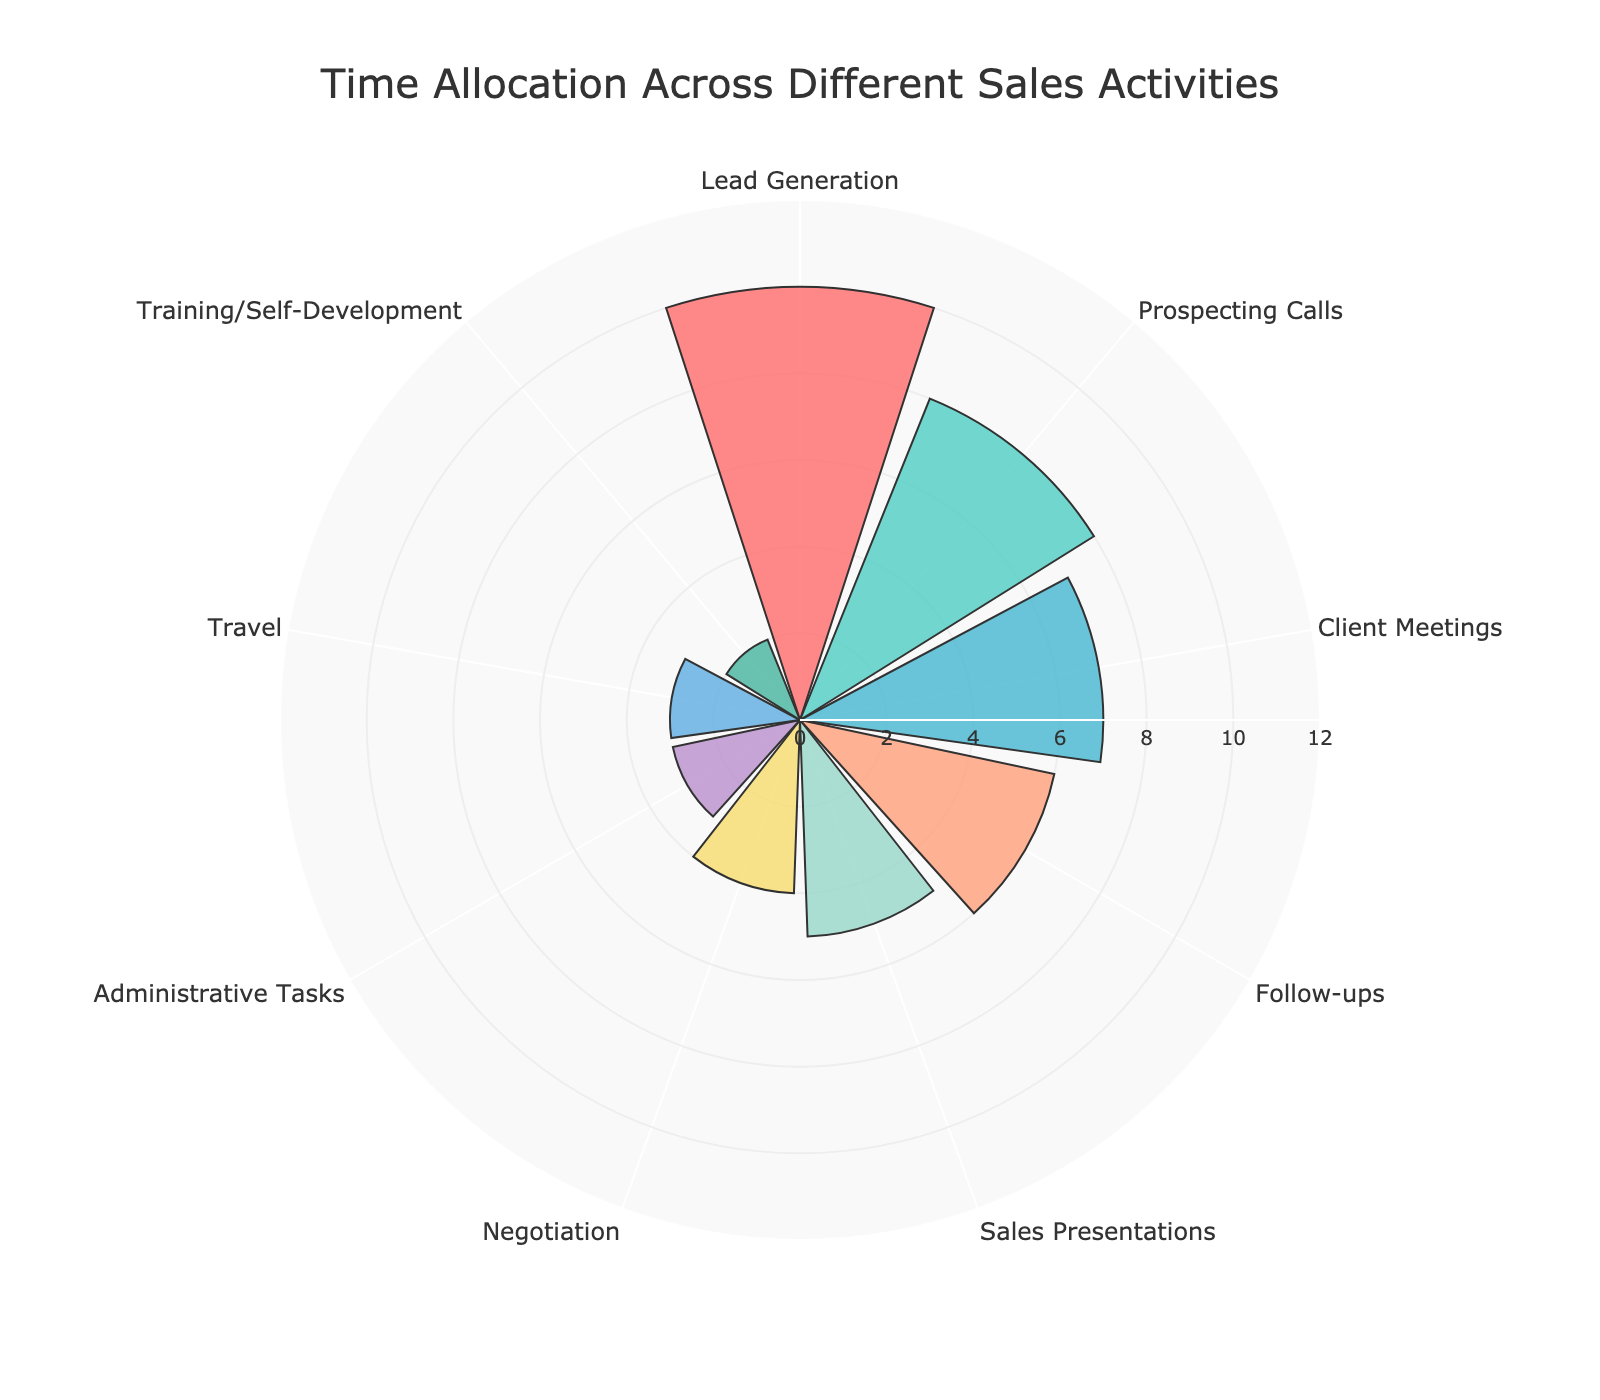what is the title of the figure? The title of the figure is displayed at the top of the chart. It is "Time Allocation Across Different Sales Activities".
Answer: Time Allocation Across Different Sales Activities how many activities are shown in the chart? By counting the segments labeled around the polar area chart, there are 9 different activities displayed.
Answer: 9 which activity takes the most hours per week? The activity with the longest bar (largest radius) represents the most hours. "Lead Generation" takes the most time with 10 hours per week.
Answer: Lead Generation how many more hours are spent on lead generation than on administrative tasks? Lead Generation takes 10 hours and Administrative Tasks take 3 hours. The difference is 10 - 3.
Answer: 7 what activities take 5 or more hours per week? By observing the chart and identifying the bars with radii of 5 or more hours, the activities are: Lead Generation (10), Prospecting Calls (8), Client Meetings (7), Follow-ups (6), and Sales Presentations (5).
Answer: Lead Generation, Prospecting Calls, Client Meetings, Follow-ups, Sales Presentations what is the combined amount of time spent on negotiation and sales presentations? Negotiation takes 4 hours and Sales Presentations take 5 hours per week. The total time combined is 4 + 5.
Answer: 9 are any activities allocated the same amount of time per week? By examining the lengths of the bars, Travel and Administrative Tasks both take 3 hours per week.
Answer: Yes, Travel and Administrative Tasks which activity has the shortest amount of time allocated? The shortest bar in the chart corresponds to the activity with the least time, and that activity is Training/Self-Development, which has 2 hours allocated per week.
Answer: Training/Self-Development how much more time is spent on client meetings compared to training/self-development? Client Meetings take 7 hours per week and Training/Self-Development takes 2 hours per week. The difference is 7 - 2.
Answer: 5 what is the total time spent on all activities combined? Sum the hours of all activities: 10 (Lead Generation) + 8 (Prospecting Calls) + 6 (Follow-ups) + 5 (Sales Presentations) + 4 (Negotiation) + 3 (Administrative Tasks) + 7 (Client Meetings) + 2 (Training/Self-Development) + 3 (Travel).
Answer: 48 